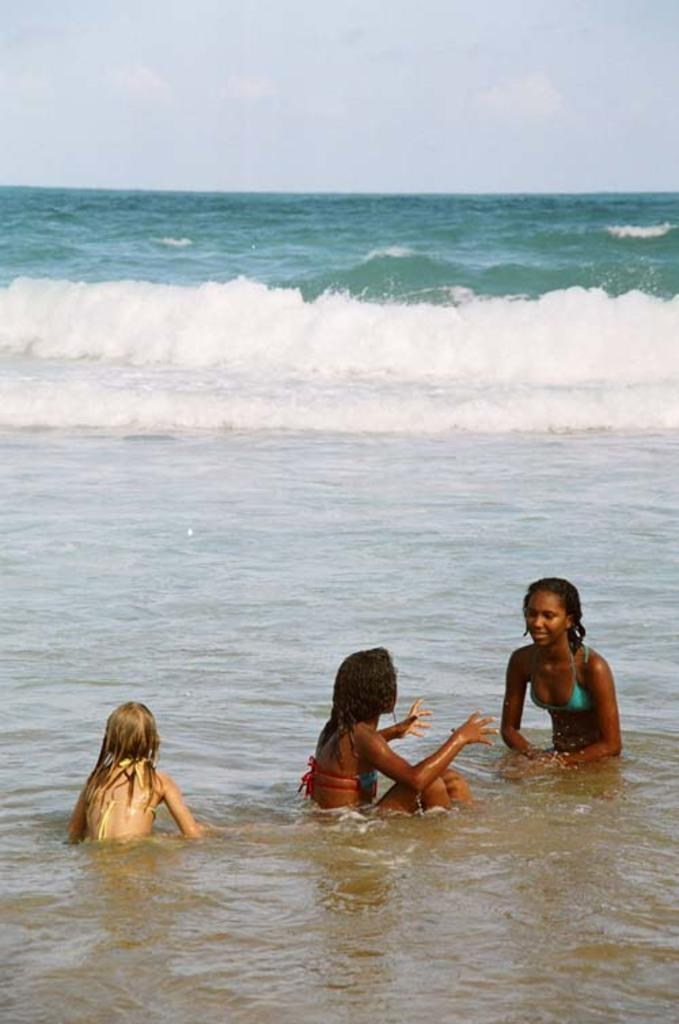What are the people in the image doing? The people in the image are in the water. What can be seen in the background of the image? There is a sea visible in the background of the image, and the sky is also visible. Can you see a window in the image? There is no window present in the image; it features people in the water with a sea and sky in the background. 